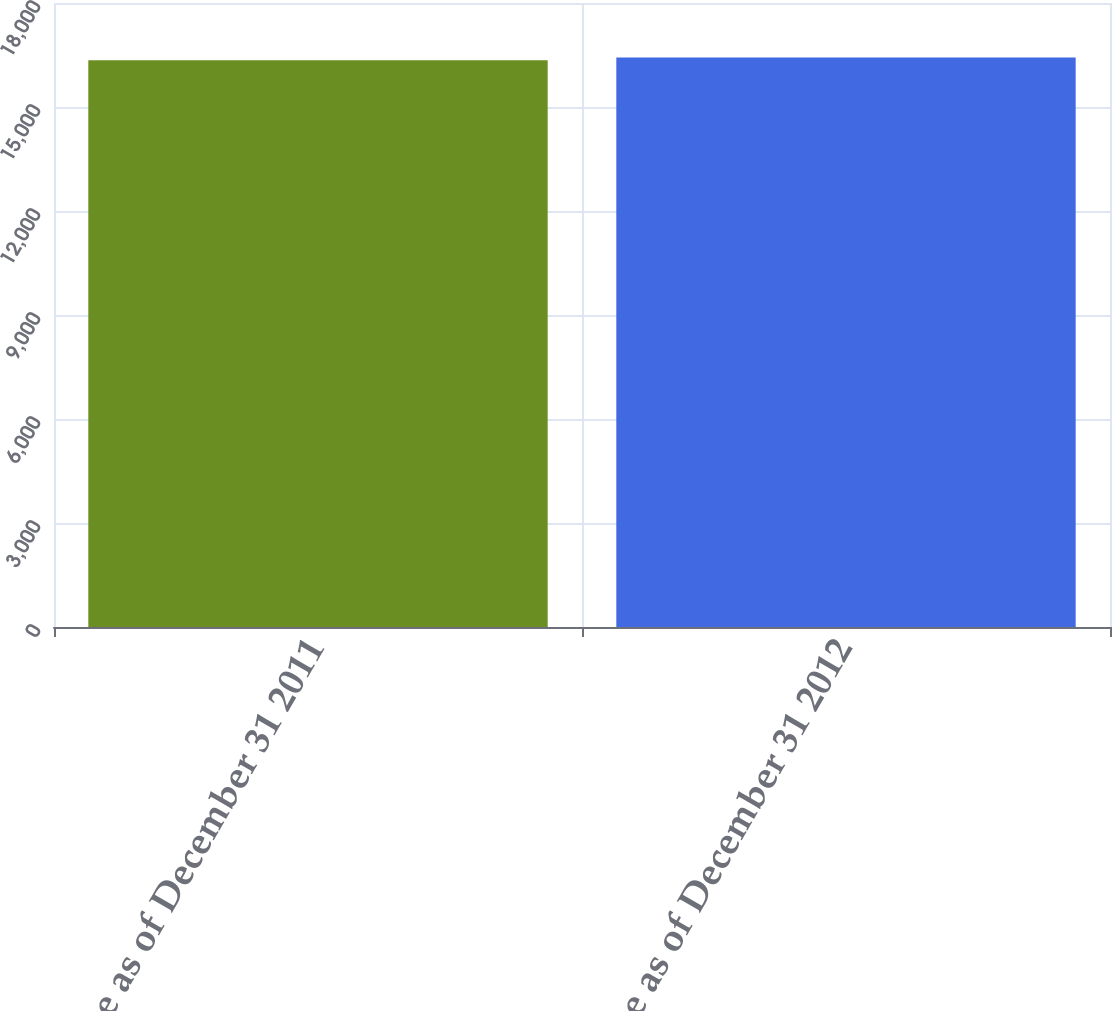Convert chart. <chart><loc_0><loc_0><loc_500><loc_500><bar_chart><fcel>Balance as of December 31 2011<fcel>Balance as of December 31 2012<nl><fcel>16349<fcel>16429<nl></chart> 